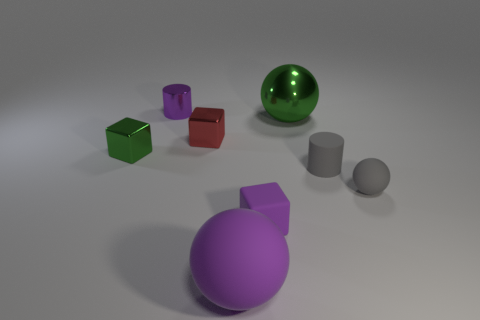What color is the small matte thing that is the same shape as the small red shiny object?
Provide a succinct answer. Purple. What number of other purple things have the same shape as the small purple rubber thing?
Keep it short and to the point. 0. How many objects are either big metal objects or metal cubes that are on the left side of the red metallic cube?
Ensure brevity in your answer.  2. Is the color of the big rubber ball the same as the cylinder to the left of the small purple matte cube?
Provide a short and direct response. Yes. What is the size of the object that is both in front of the gray matte cylinder and to the right of the purple cube?
Keep it short and to the point. Small. Are there any purple rubber blocks on the left side of the small green metallic object?
Your answer should be compact. No. Is there a tiny green metal object that is left of the tiny cylinder in front of the small green block?
Provide a succinct answer. Yes. Are there an equal number of green shiny balls in front of the big green ball and small purple matte cubes behind the purple rubber cube?
Make the answer very short. Yes. The cylinder that is made of the same material as the red block is what color?
Keep it short and to the point. Purple. Is there a big purple ball made of the same material as the gray ball?
Provide a succinct answer. Yes. 